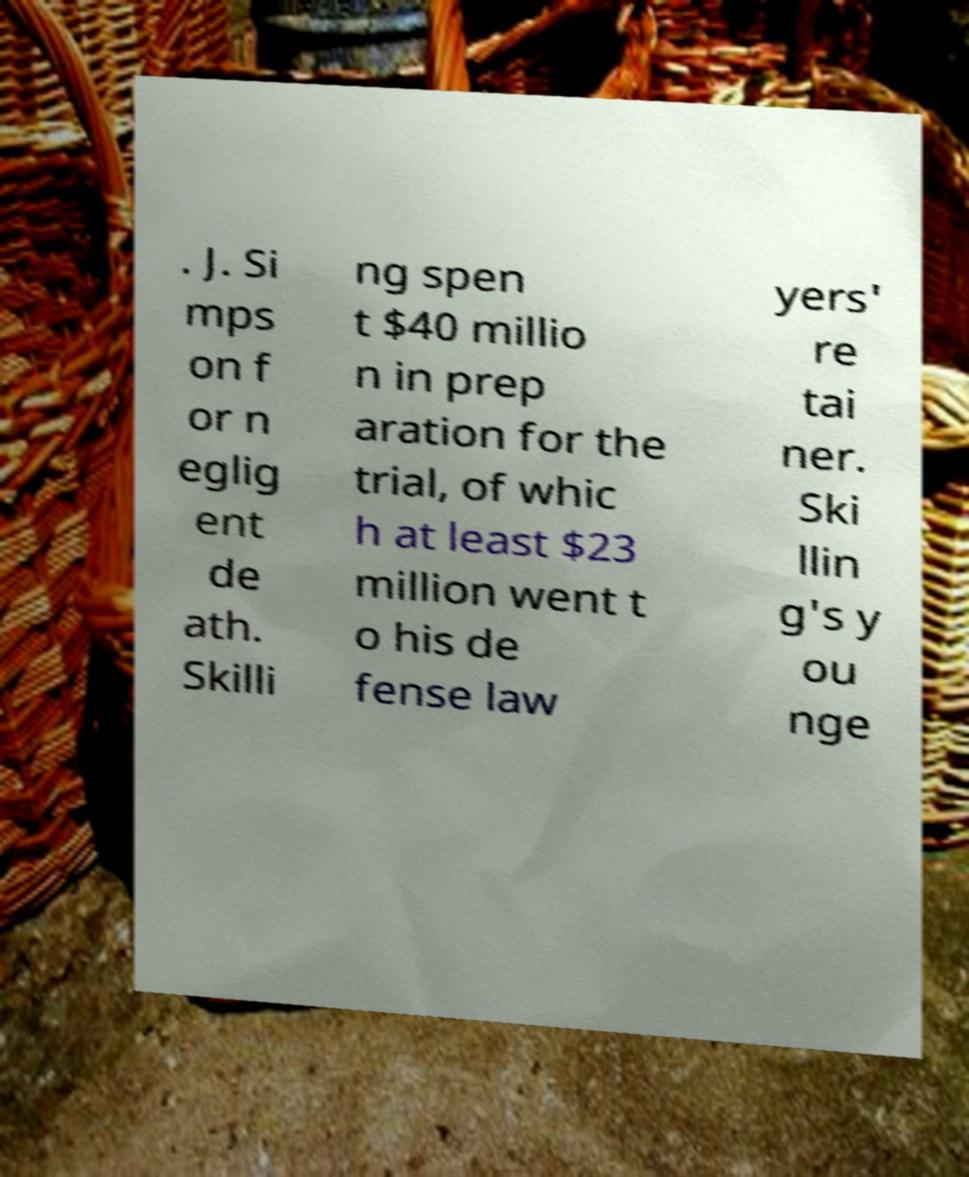Please read and relay the text visible in this image. What does it say? . J. Si mps on f or n eglig ent de ath. Skilli ng spen t $40 millio n in prep aration for the trial, of whic h at least $23 million went t o his de fense law yers' re tai ner. Ski llin g's y ou nge 